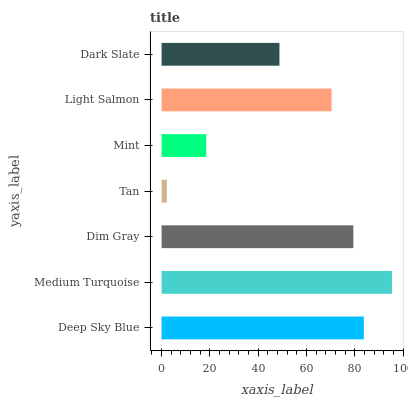Is Tan the minimum?
Answer yes or no. Yes. Is Medium Turquoise the maximum?
Answer yes or no. Yes. Is Dim Gray the minimum?
Answer yes or no. No. Is Dim Gray the maximum?
Answer yes or no. No. Is Medium Turquoise greater than Dim Gray?
Answer yes or no. Yes. Is Dim Gray less than Medium Turquoise?
Answer yes or no. Yes. Is Dim Gray greater than Medium Turquoise?
Answer yes or no. No. Is Medium Turquoise less than Dim Gray?
Answer yes or no. No. Is Light Salmon the high median?
Answer yes or no. Yes. Is Light Salmon the low median?
Answer yes or no. Yes. Is Dim Gray the high median?
Answer yes or no. No. Is Medium Turquoise the low median?
Answer yes or no. No. 